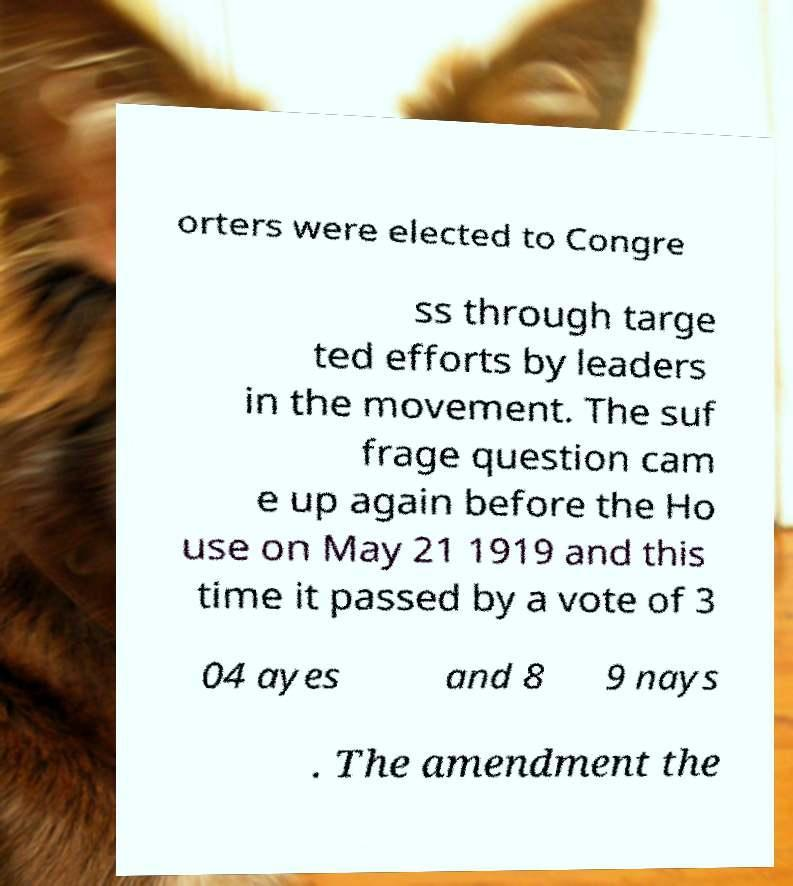Could you assist in decoding the text presented in this image and type it out clearly? orters were elected to Congre ss through targe ted efforts by leaders in the movement. The suf frage question cam e up again before the Ho use on May 21 1919 and this time it passed by a vote of 3 04 ayes and 8 9 nays . The amendment the 